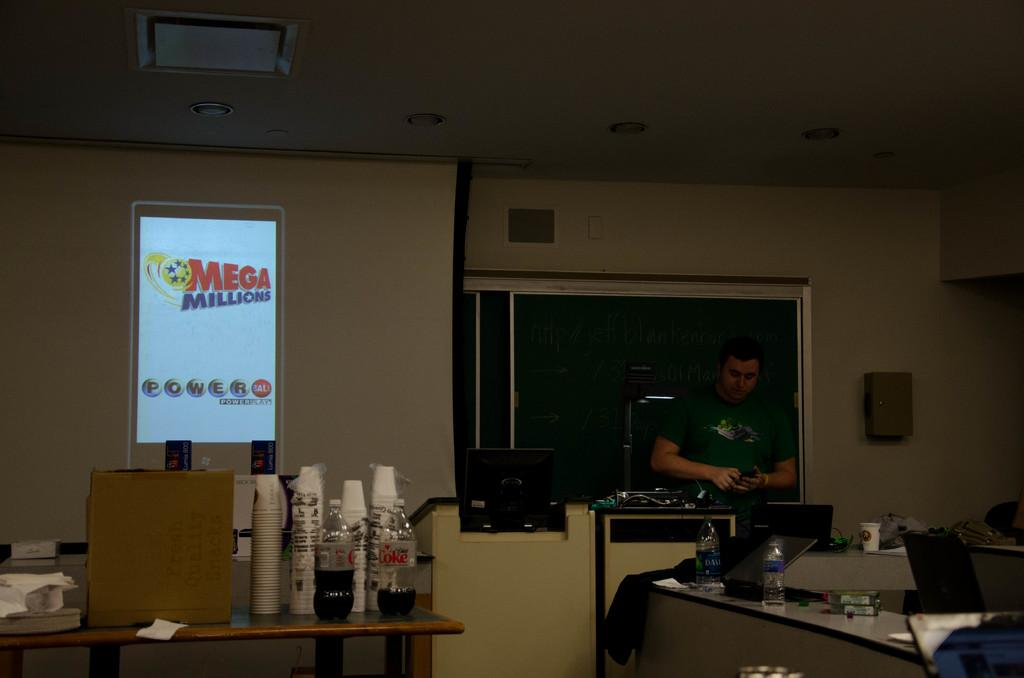<image>
Create a compact narrative representing the image presented. A screen displays the Mega Millions and Power Ball lottery logos. 